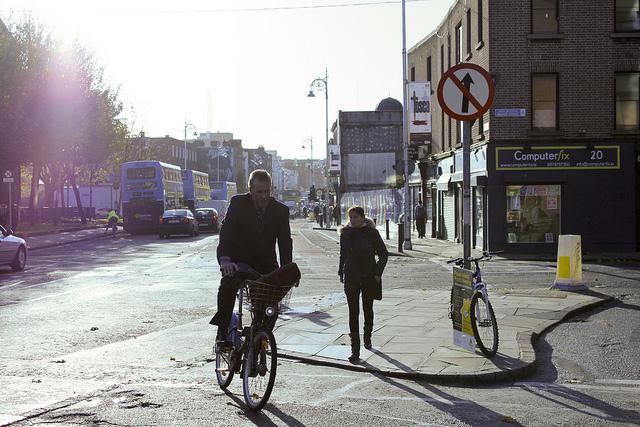What is the man riding?
Quick response, please. Bike. How many bikes are pictured?
Keep it brief. 2. Is the woman following the man on the bike?
Concise answer only. No. Is this outdoors?
Concise answer only. Yes. 